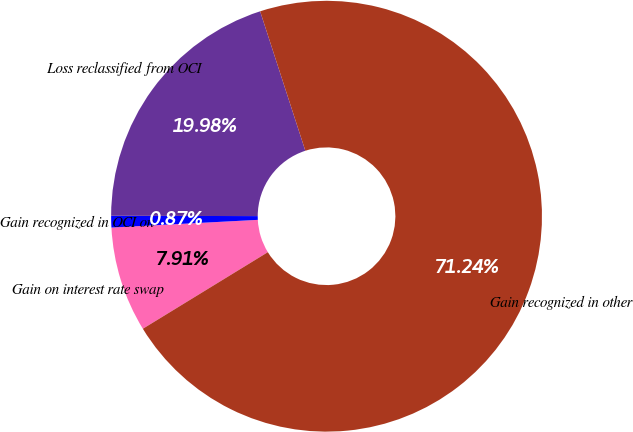<chart> <loc_0><loc_0><loc_500><loc_500><pie_chart><fcel>Gain on interest rate swap<fcel>Gain recognized in OCI on<fcel>Loss reclassified from OCI<fcel>Gain recognized in other<nl><fcel>7.91%<fcel>0.87%<fcel>19.98%<fcel>71.24%<nl></chart> 